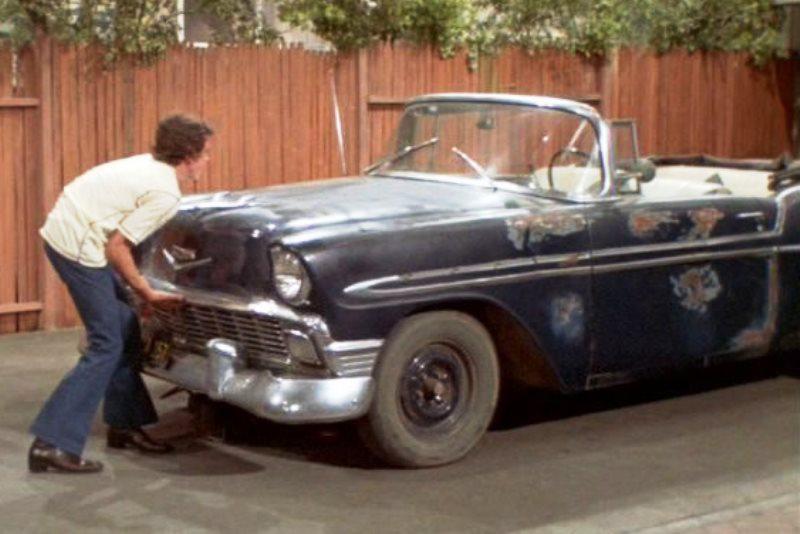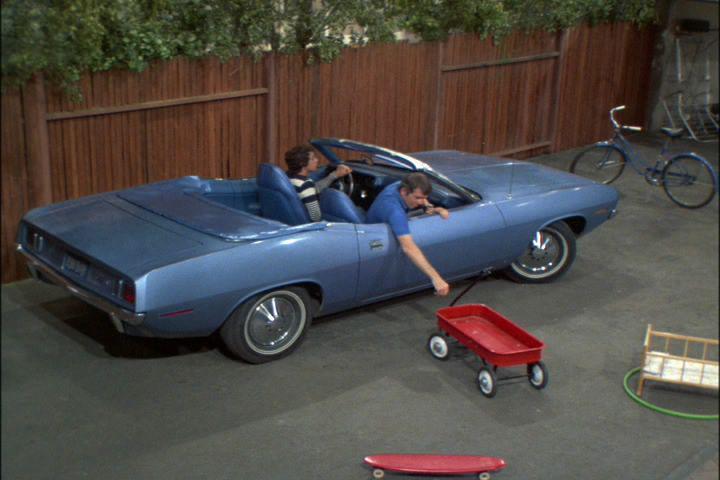The first image is the image on the left, the second image is the image on the right. Considering the images on both sides, is "In the right image, there is a blue convertible facing the right" valid? Answer yes or no. Yes. 